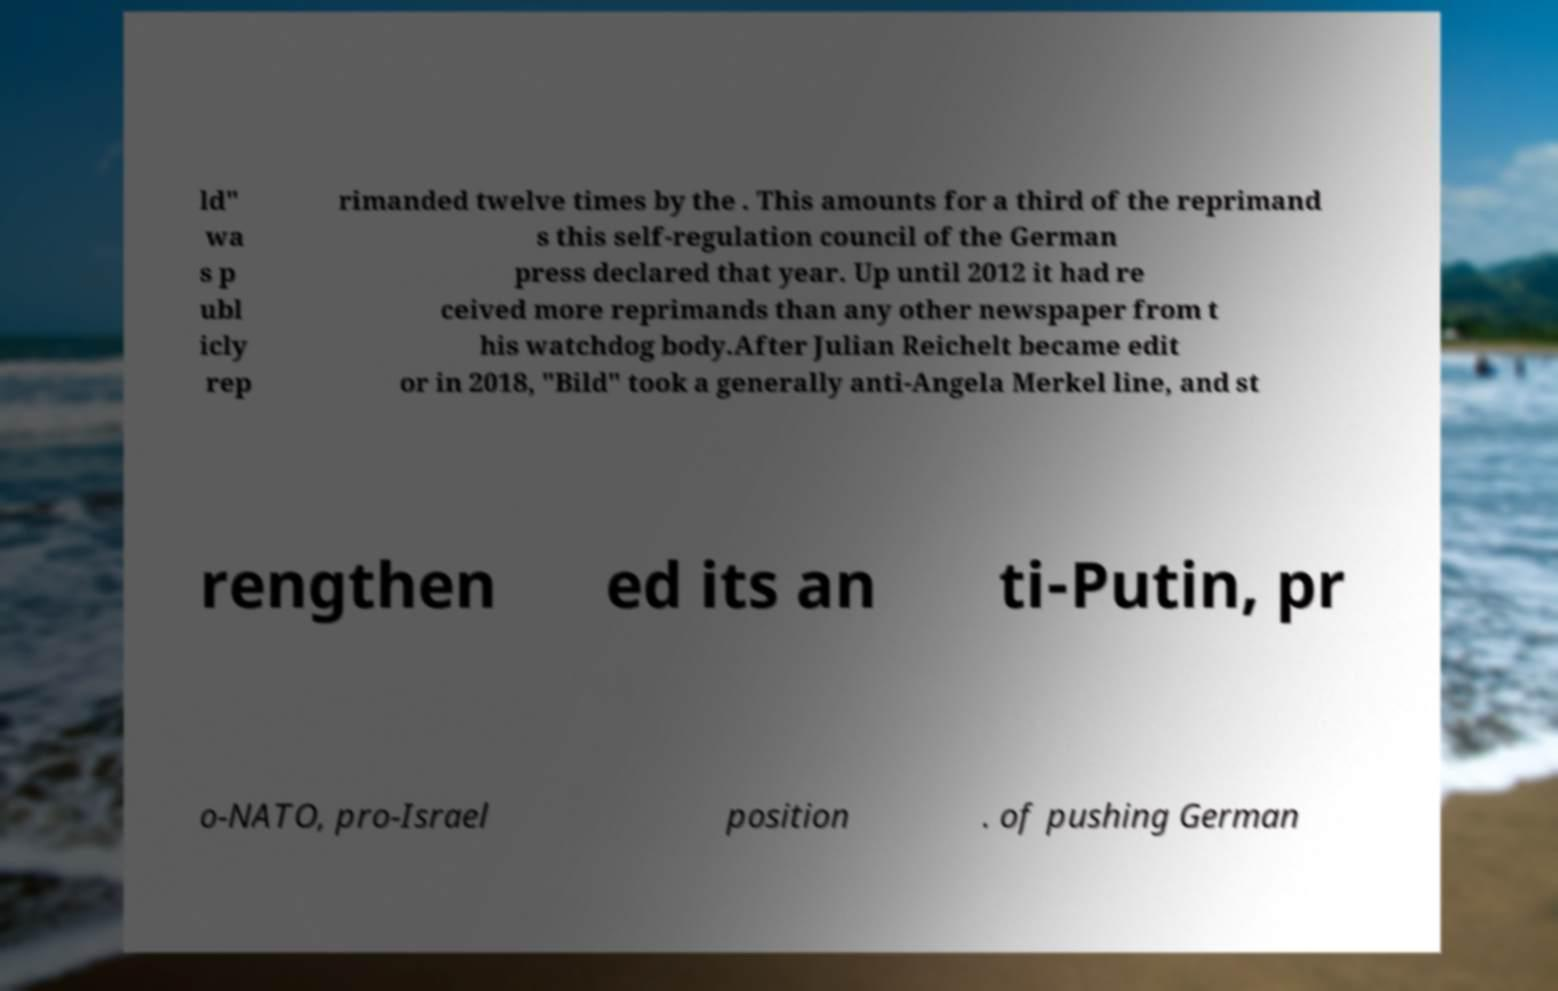I need the written content from this picture converted into text. Can you do that? ld" wa s p ubl icly rep rimanded twelve times by the . This amounts for a third of the reprimand s this self-regulation council of the German press declared that year. Up until 2012 it had re ceived more reprimands than any other newspaper from t his watchdog body.After Julian Reichelt became edit or in 2018, "Bild" took a generally anti-Angela Merkel line, and st rengthen ed its an ti-Putin, pr o-NATO, pro-Israel position . of pushing German 